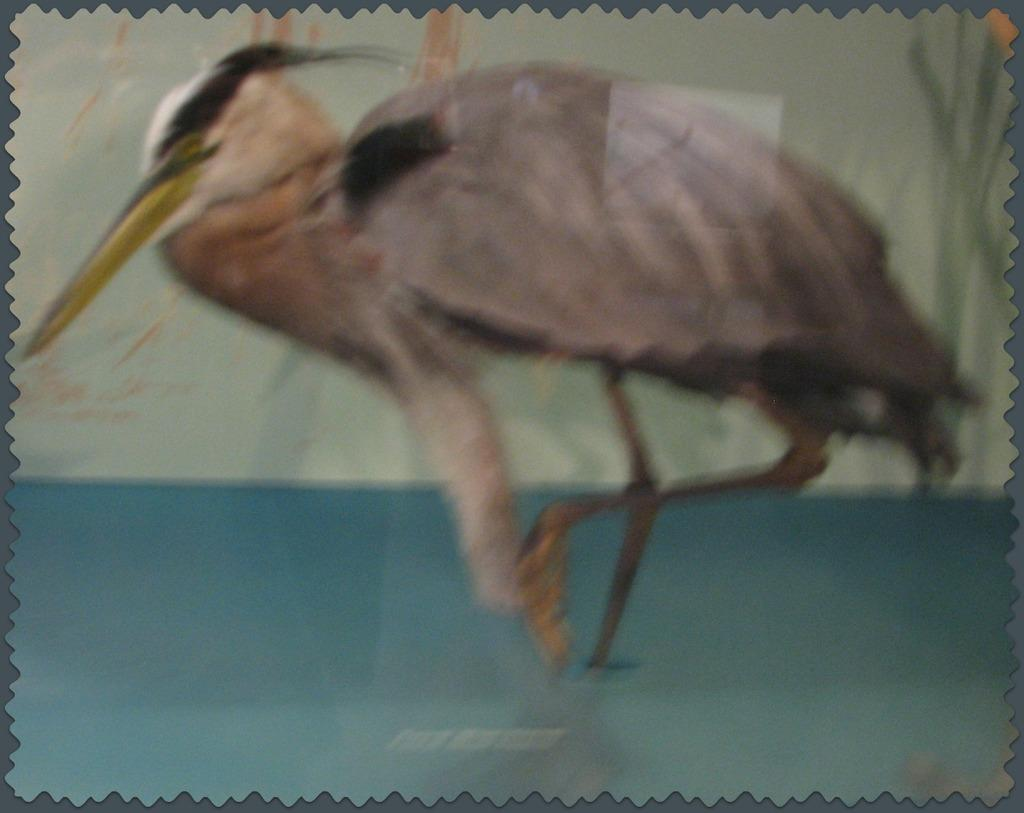What is the main subject of the image? There is a painting in the image. What is depicted in the painting? The painting contains a crane and water. How many clovers can be seen in the painting? There are no clovers present in the painting; it features a crane and water. What type of fowl is shown interacting with the crane in the painting? There is no fowl shown interacting with the crane in the painting; only the crane and water are present. 